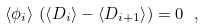<formula> <loc_0><loc_0><loc_500><loc_500>\left < \phi _ { i } \right > \, \left ( \left < D _ { i } \right > - \left < D _ { i + 1 } \right > \right ) = 0 \ ,</formula> 